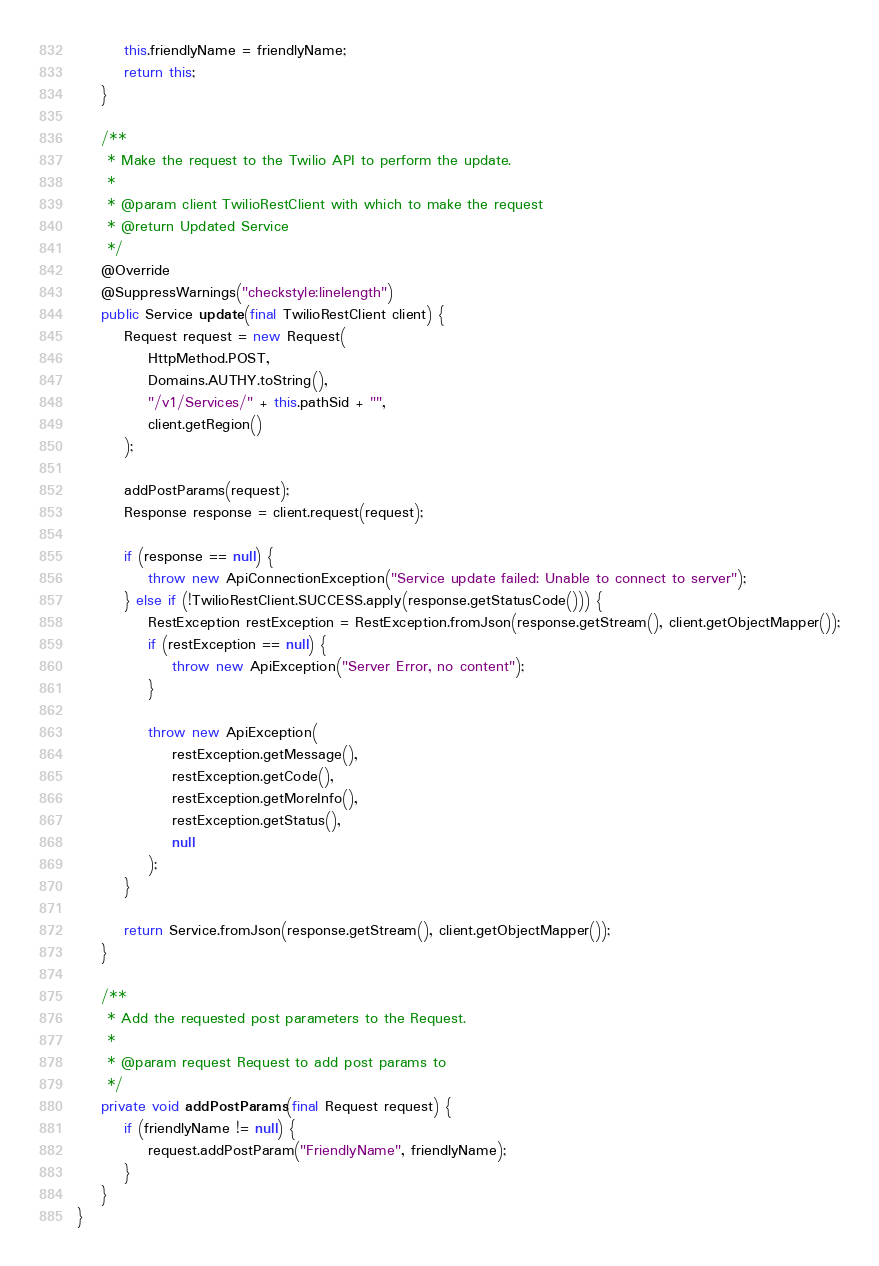<code> <loc_0><loc_0><loc_500><loc_500><_Java_>        this.friendlyName = friendlyName;
        return this;
    }

    /**
     * Make the request to the Twilio API to perform the update.
     * 
     * @param client TwilioRestClient with which to make the request
     * @return Updated Service
     */
    @Override
    @SuppressWarnings("checkstyle:linelength")
    public Service update(final TwilioRestClient client) {
        Request request = new Request(
            HttpMethod.POST,
            Domains.AUTHY.toString(),
            "/v1/Services/" + this.pathSid + "",
            client.getRegion()
        );

        addPostParams(request);
        Response response = client.request(request);

        if (response == null) {
            throw new ApiConnectionException("Service update failed: Unable to connect to server");
        } else if (!TwilioRestClient.SUCCESS.apply(response.getStatusCode())) {
            RestException restException = RestException.fromJson(response.getStream(), client.getObjectMapper());
            if (restException == null) {
                throw new ApiException("Server Error, no content");
            }

            throw new ApiException(
                restException.getMessage(),
                restException.getCode(),
                restException.getMoreInfo(),
                restException.getStatus(),
                null
            );
        }

        return Service.fromJson(response.getStream(), client.getObjectMapper());
    }

    /**
     * Add the requested post parameters to the Request.
     * 
     * @param request Request to add post params to
     */
    private void addPostParams(final Request request) {
        if (friendlyName != null) {
            request.addPostParam("FriendlyName", friendlyName);
        }
    }
}</code> 